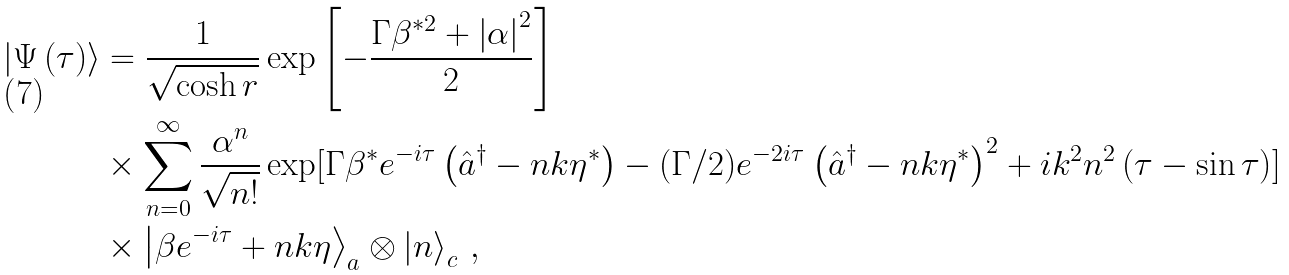Convert formula to latex. <formula><loc_0><loc_0><loc_500><loc_500>\left | \Psi \left ( \tau \right ) \right \rangle & = \frac { 1 } { \sqrt { \cosh r } } \exp \left [ { - \frac { \Gamma \beta ^ { \ast 2 } + \left | \alpha \right | ^ { 2 } } { 2 } } \right ] \\ & \times \sum _ { n = 0 } ^ { \infty } \frac { \alpha ^ { n } } { \sqrt { n ! } } \exp [ \Gamma \beta ^ { \ast } e ^ { - i \tau } \left ( \hat { a } ^ { \dagger } - n k \eta ^ { \ast } \right ) - ( \Gamma / 2 ) e ^ { - 2 i \tau } \left ( \hat { a } ^ { \dagger } - n k \eta ^ { \ast } \right ) ^ { 2 } + i k ^ { 2 } n ^ { 2 } \left ( \tau - \sin \tau \right ) ] \\ & \times \left | \beta e ^ { - i \tau } + n k \eta \right \rangle _ { a } \otimes \left | n \right \rangle _ { c } \, ,</formula> 